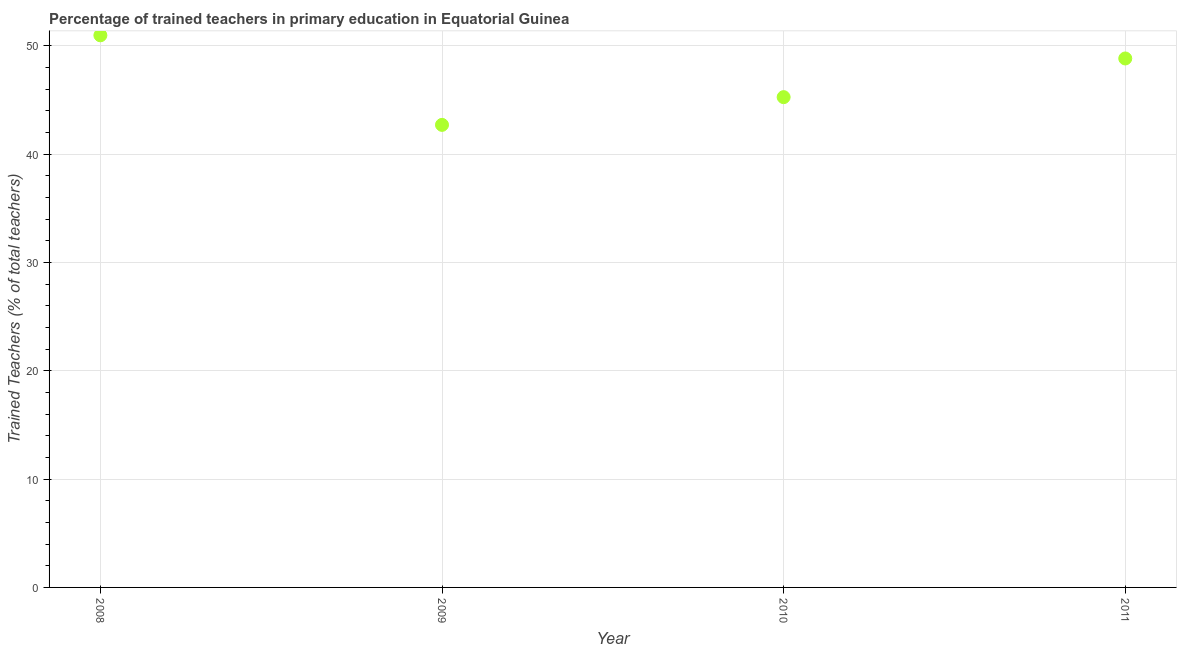What is the percentage of trained teachers in 2010?
Your response must be concise. 45.26. Across all years, what is the maximum percentage of trained teachers?
Your response must be concise. 50.97. Across all years, what is the minimum percentage of trained teachers?
Offer a very short reply. 42.7. In which year was the percentage of trained teachers minimum?
Offer a terse response. 2009. What is the sum of the percentage of trained teachers?
Your answer should be compact. 187.75. What is the difference between the percentage of trained teachers in 2008 and 2009?
Make the answer very short. 8.27. What is the average percentage of trained teachers per year?
Keep it short and to the point. 46.94. What is the median percentage of trained teachers?
Provide a succinct answer. 47.04. In how many years, is the percentage of trained teachers greater than 6 %?
Your answer should be compact. 4. What is the ratio of the percentage of trained teachers in 2009 to that in 2010?
Give a very brief answer. 0.94. Is the difference between the percentage of trained teachers in 2009 and 2010 greater than the difference between any two years?
Give a very brief answer. No. What is the difference between the highest and the second highest percentage of trained teachers?
Your answer should be very brief. 2.14. What is the difference between the highest and the lowest percentage of trained teachers?
Your answer should be compact. 8.27. How many years are there in the graph?
Provide a succinct answer. 4. Does the graph contain grids?
Keep it short and to the point. Yes. What is the title of the graph?
Provide a short and direct response. Percentage of trained teachers in primary education in Equatorial Guinea. What is the label or title of the Y-axis?
Offer a terse response. Trained Teachers (% of total teachers). What is the Trained Teachers (% of total teachers) in 2008?
Your response must be concise. 50.97. What is the Trained Teachers (% of total teachers) in 2009?
Offer a very short reply. 42.7. What is the Trained Teachers (% of total teachers) in 2010?
Your answer should be compact. 45.26. What is the Trained Teachers (% of total teachers) in 2011?
Keep it short and to the point. 48.83. What is the difference between the Trained Teachers (% of total teachers) in 2008 and 2009?
Your response must be concise. 8.27. What is the difference between the Trained Teachers (% of total teachers) in 2008 and 2010?
Your answer should be very brief. 5.71. What is the difference between the Trained Teachers (% of total teachers) in 2008 and 2011?
Ensure brevity in your answer.  2.14. What is the difference between the Trained Teachers (% of total teachers) in 2009 and 2010?
Provide a succinct answer. -2.56. What is the difference between the Trained Teachers (% of total teachers) in 2009 and 2011?
Your response must be concise. -6.13. What is the difference between the Trained Teachers (% of total teachers) in 2010 and 2011?
Offer a very short reply. -3.57. What is the ratio of the Trained Teachers (% of total teachers) in 2008 to that in 2009?
Ensure brevity in your answer.  1.19. What is the ratio of the Trained Teachers (% of total teachers) in 2008 to that in 2010?
Offer a terse response. 1.13. What is the ratio of the Trained Teachers (% of total teachers) in 2008 to that in 2011?
Your response must be concise. 1.04. What is the ratio of the Trained Teachers (% of total teachers) in 2009 to that in 2010?
Give a very brief answer. 0.94. What is the ratio of the Trained Teachers (% of total teachers) in 2009 to that in 2011?
Ensure brevity in your answer.  0.87. What is the ratio of the Trained Teachers (% of total teachers) in 2010 to that in 2011?
Offer a very short reply. 0.93. 